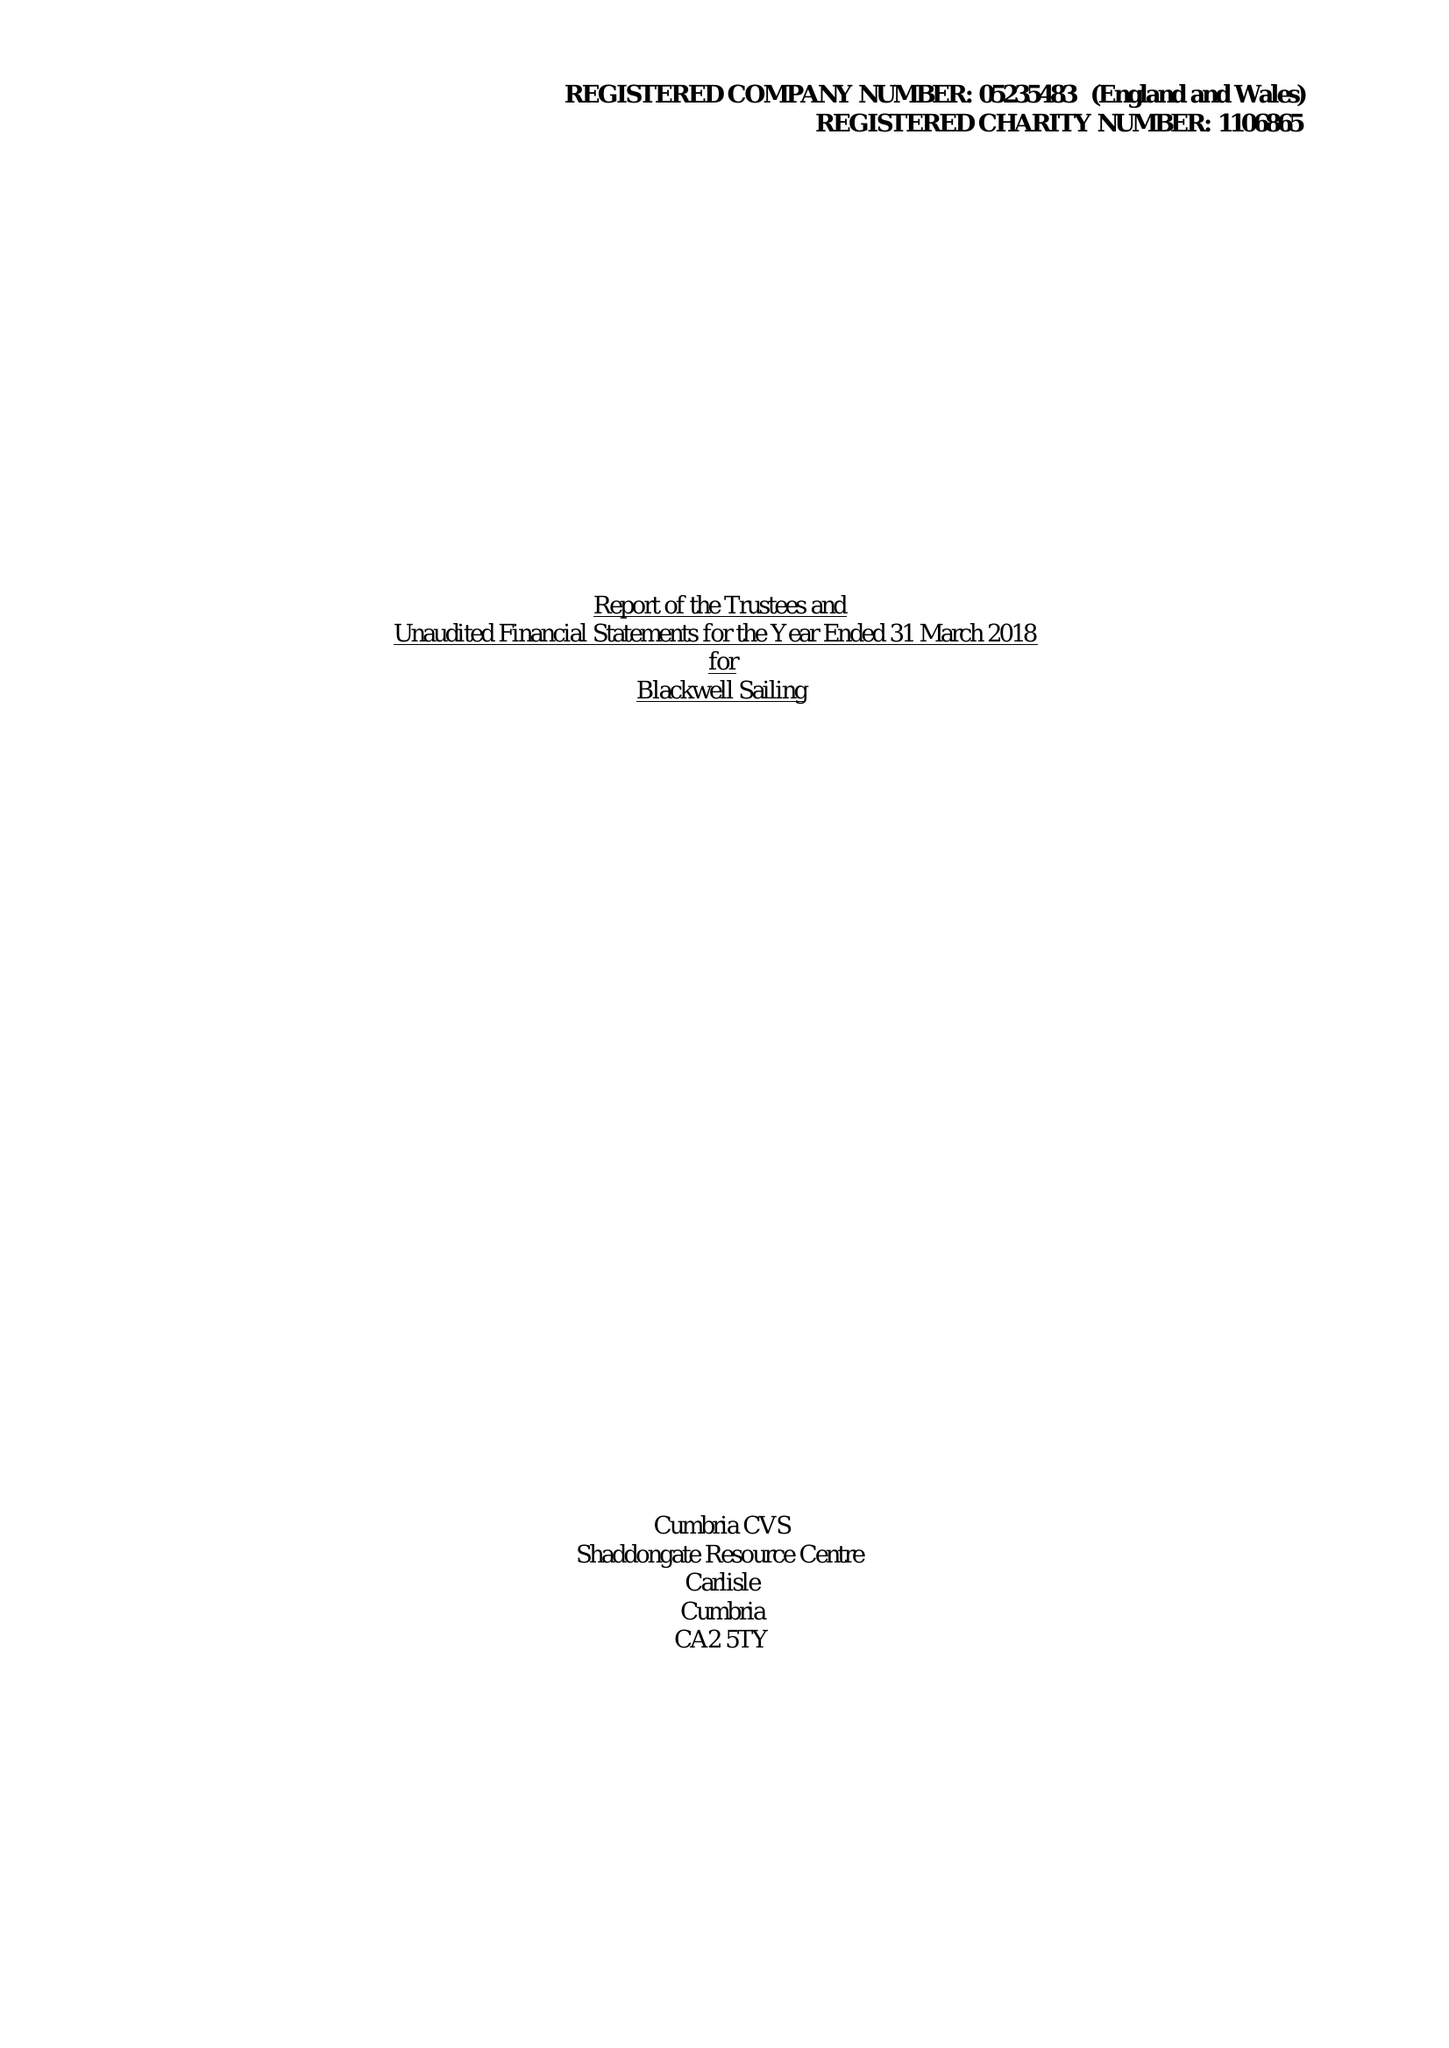What is the value for the address__street_line?
Answer the question using a single word or phrase. GLEBE ROAD 